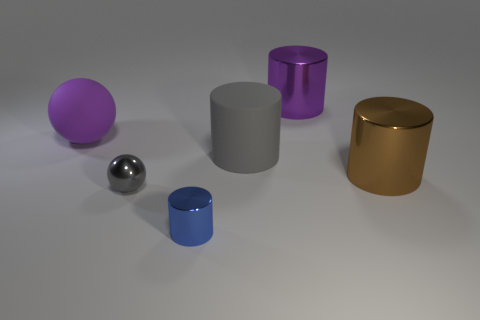Subtract all large cylinders. How many cylinders are left? 1 Add 3 purple spheres. How many objects exist? 9 Subtract all purple cylinders. How many cylinders are left? 3 Subtract 1 cylinders. How many cylinders are left? 3 Subtract all balls. How many objects are left? 4 Subtract all blue cylinders. Subtract all blue balls. How many cylinders are left? 3 Add 1 large red rubber spheres. How many large red rubber spheres exist? 1 Subtract 0 red cylinders. How many objects are left? 6 Subtract all large green metallic spheres. Subtract all metal cylinders. How many objects are left? 3 Add 4 big things. How many big things are left? 8 